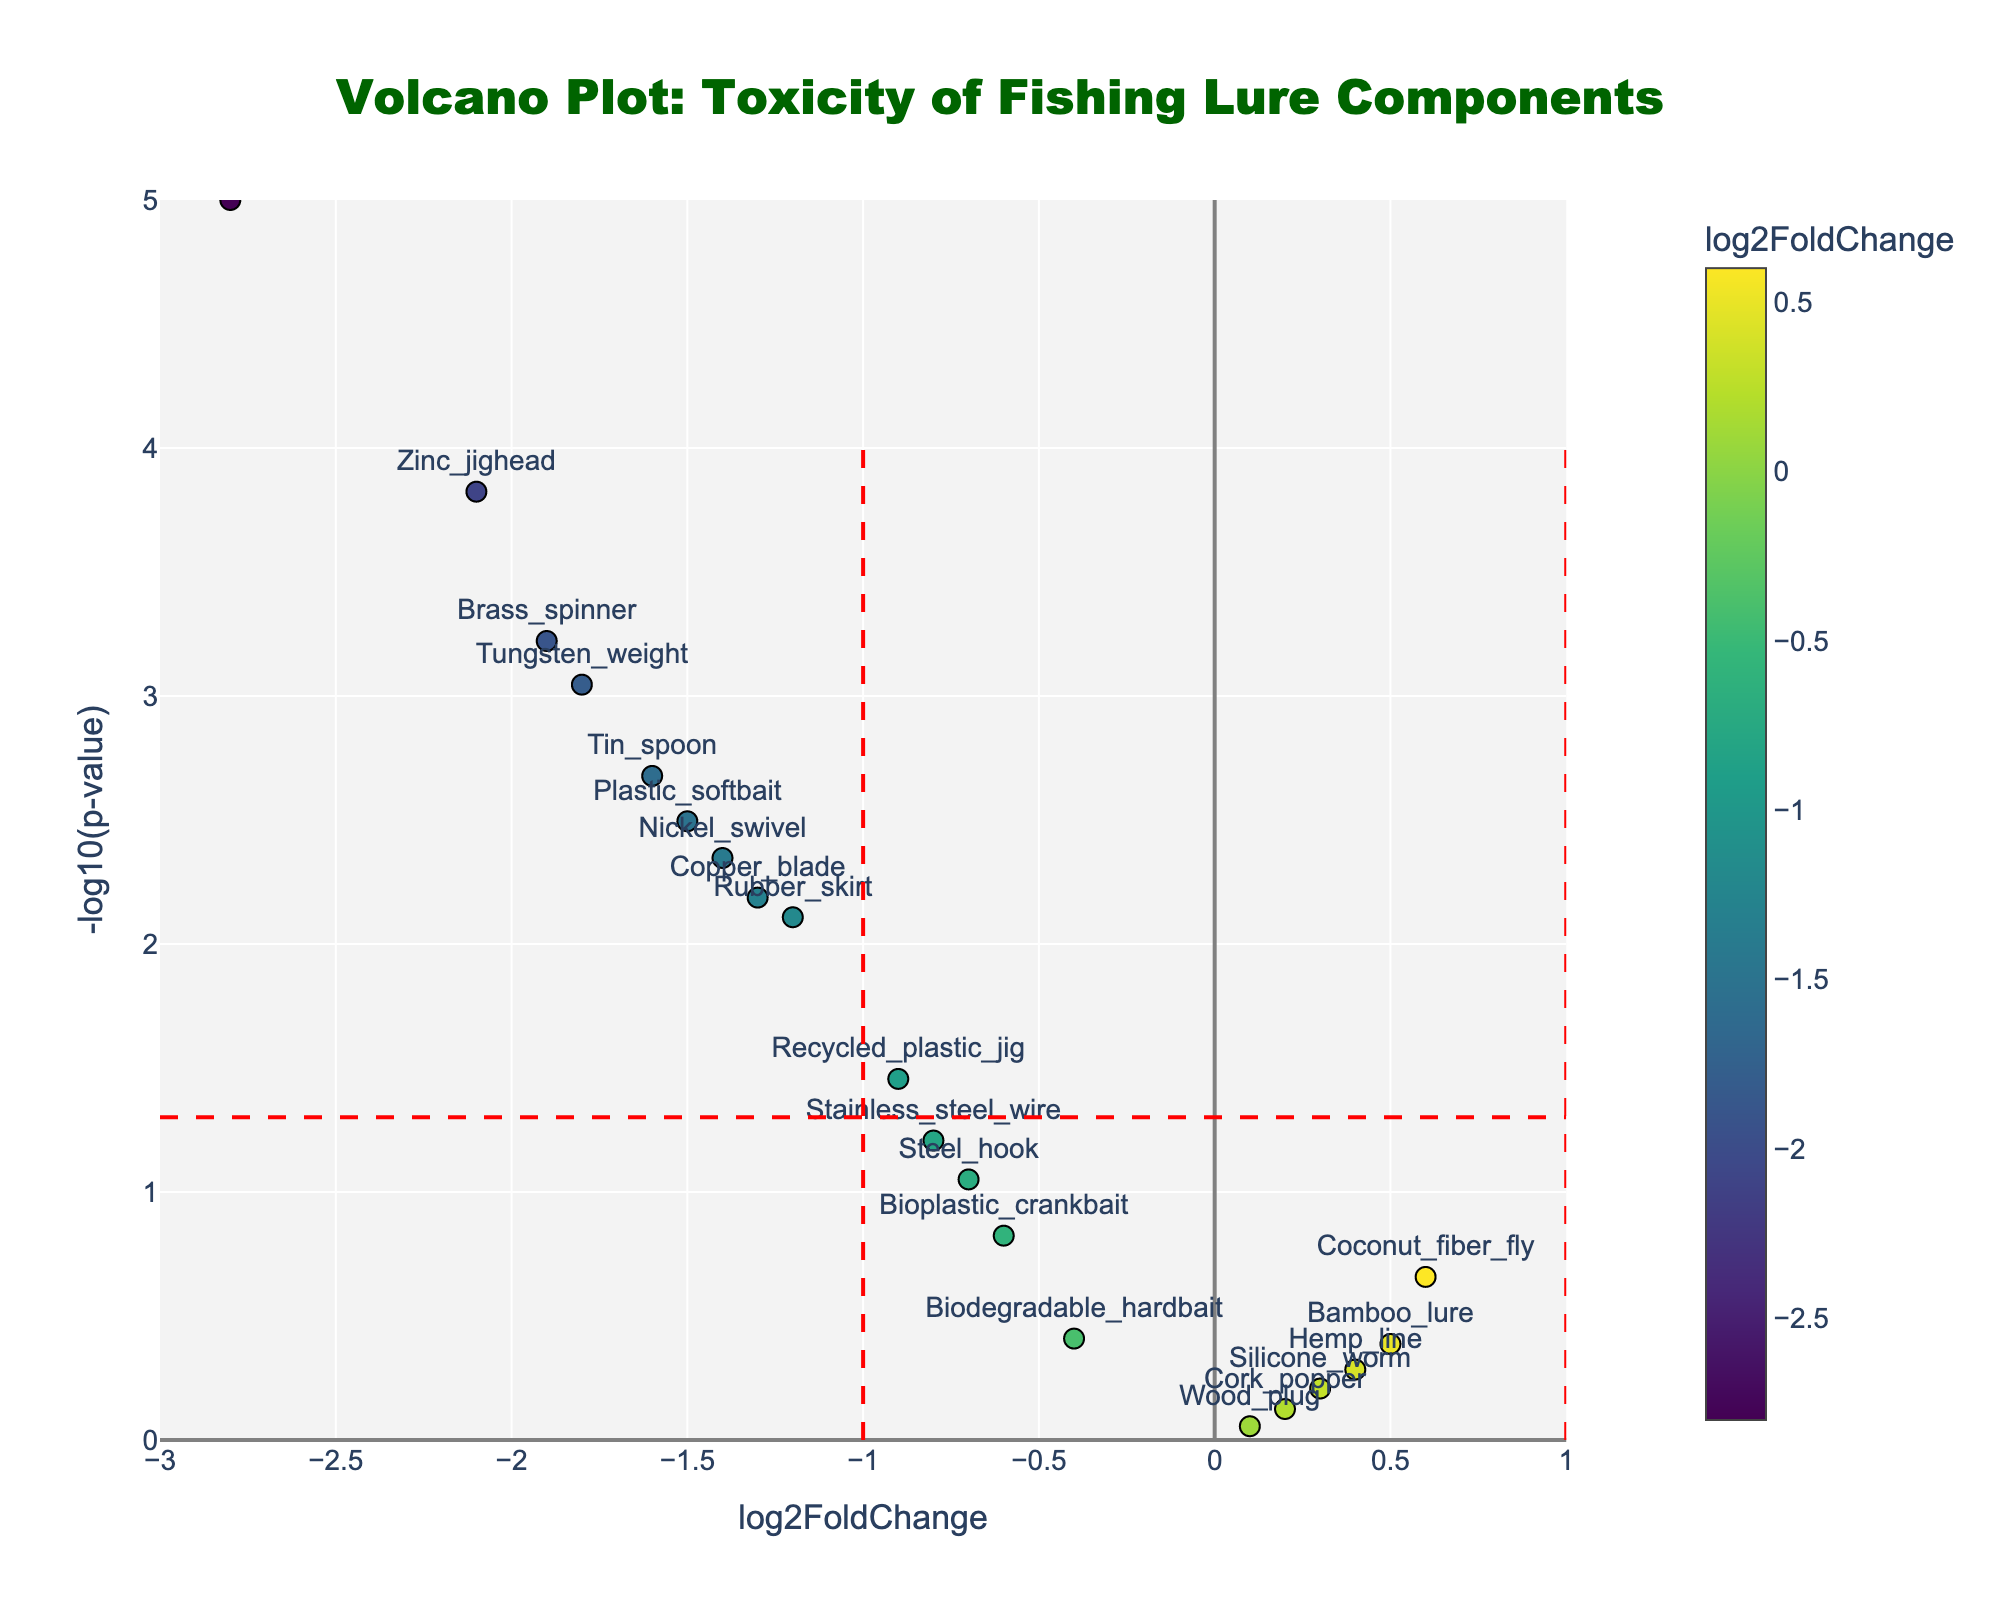What's the title of the plot? The title is usually found at the top of the plot and provides a summary of what the plot is about. Here, it reads, "Volcano Plot: Toxicity of Fishing Lure Components".
Answer: "Volcano Plot: Toxicity of Fishing Lure Components" What do the x-axis and y-axis represent? The x-axis represents "log2FoldChange" which measures the fold change in toxicity, and the y-axis represents "-log10(p-value)" which indicates the statistical significance of the changes.
Answer: "log2FoldChange" and "-log10(p-value)" How many data points are significantly toxic (p-value < 0.05) and have a negative log2FoldChange? First, identify data points above the horizontal line (significant) in the left part of the plot (negative log2FoldChange). Then count these points. They are Lead_sinker, Plastic_softbait, Zinc_jighead, Rubber_skirt, Tungsten_weight, Nickel_swivel, Brass_spinner, Tin_spoon, and Copper_blade.
Answer: 9 Which fishing lure component shows the least significant change in toxicity? Look at the data point closest to the y-axis' origin (low -log10(p-value)) and identify the component. The Cork_popper has a p-value resulting in the lowest -log10(p-value).
Answer: Cork_popper Name a fishing lure component that has increased toxicity with a high significance level. Check for points with positive log2FoldChange (right side of the plot) and high y-values (above the horizontal threshold). No points meet both criteria, so there are none.
Answer: None Among the significantly toxic components (p-value < 0.05), which one has the highest fold change? For this, find the point with the largest absolute negative log2FoldChange among significant points: Lead_sinker with a log2FoldChange of -2.8.
Answer: Lead_sinker Which fishing lure components are considered safe based on the plot? Components with non-significant p-values (below the horizontal line) or positive log2FoldChange indicating lower toxicity are considered safe. Cork_popper, Wood_plug, Bioplastic_crankbait, Coconut_fiber_fly, Bamboo_lure, Hemp_line, and Silicone_worm fall into these categories.
Answer: Cork_popper, Wood_plug, Bioplastic_crankbait, Coconut_fiber_fly, Bamboo_lure, Hemp_line, Silicone_worm What does the color gradient of the markers indicate on the plot? The color gradient represents the log2FoldChange of toxicity values. Darker colors represent higher negative log2FoldChange (increase in toxicity), while lighter colors represent higher positive log2FoldChange (decrease in toxicity).
Answer: The log2FoldChange of toxicity How does the plot differentiate between significantly and non-significantly toxic components? The plot differentiates by having the red horizontal line marking the significance threshold of p-value = 0.05. Data points above this line are significantly toxic, while those below are not.
Answer: By the red horizontal line at -log10(p-value) of 1.3 Which sustainable alternative shows non-significant increase in toxicity? Non-significant changes can be seen from points below the red horizontal line. For increased toxicity, look for points on the right side of the y-axis. Bamboo_lure has a log2FoldChange of 0.5 but a non-significant p-value.
Answer: Bamboo_lure 